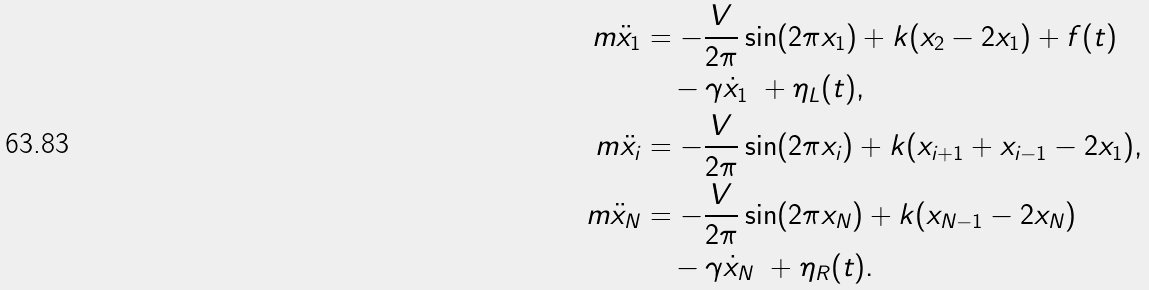<formula> <loc_0><loc_0><loc_500><loc_500>m \ddot { x } _ { 1 } & = - \frac { V } { 2 \pi } \sin ( 2 \pi x _ { 1 } ) + k ( x _ { 2 } - 2 x _ { 1 } ) + f ( t ) \quad \\ & \quad - \gamma \dot { x } _ { 1 } \ + \eta _ { L } ( t ) , \\ m \ddot { x } _ { i } & = - \frac { V } { 2 \pi } \sin ( 2 \pi x _ { i } ) + k ( x _ { i + 1 } + x _ { i - 1 } - 2 x _ { 1 } ) , \quad \\ m \ddot { x } _ { N } & = - \frac { V } { 2 \pi } \sin ( 2 \pi x _ { N } ) + k ( x _ { N - 1 } - 2 x _ { N } ) \quad \\ & \quad - \gamma \dot { x } _ { N } \ + \eta _ { R } ( t ) .</formula> 